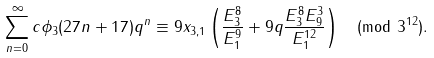Convert formula to latex. <formula><loc_0><loc_0><loc_500><loc_500>\sum _ { n = 0 } ^ { \infty } c \phi _ { 3 } ( 2 7 n + 1 7 ) q ^ { n } \equiv 9 x _ { 3 , 1 } \left ( \frac { E _ { 3 } ^ { 8 } } { E _ { 1 } ^ { 9 } } + 9 q \frac { E _ { 3 } ^ { 8 } E _ { 9 } ^ { 3 } } { E _ { 1 } ^ { 1 2 } } \right ) \pmod { 3 ^ { 1 2 } } .</formula> 